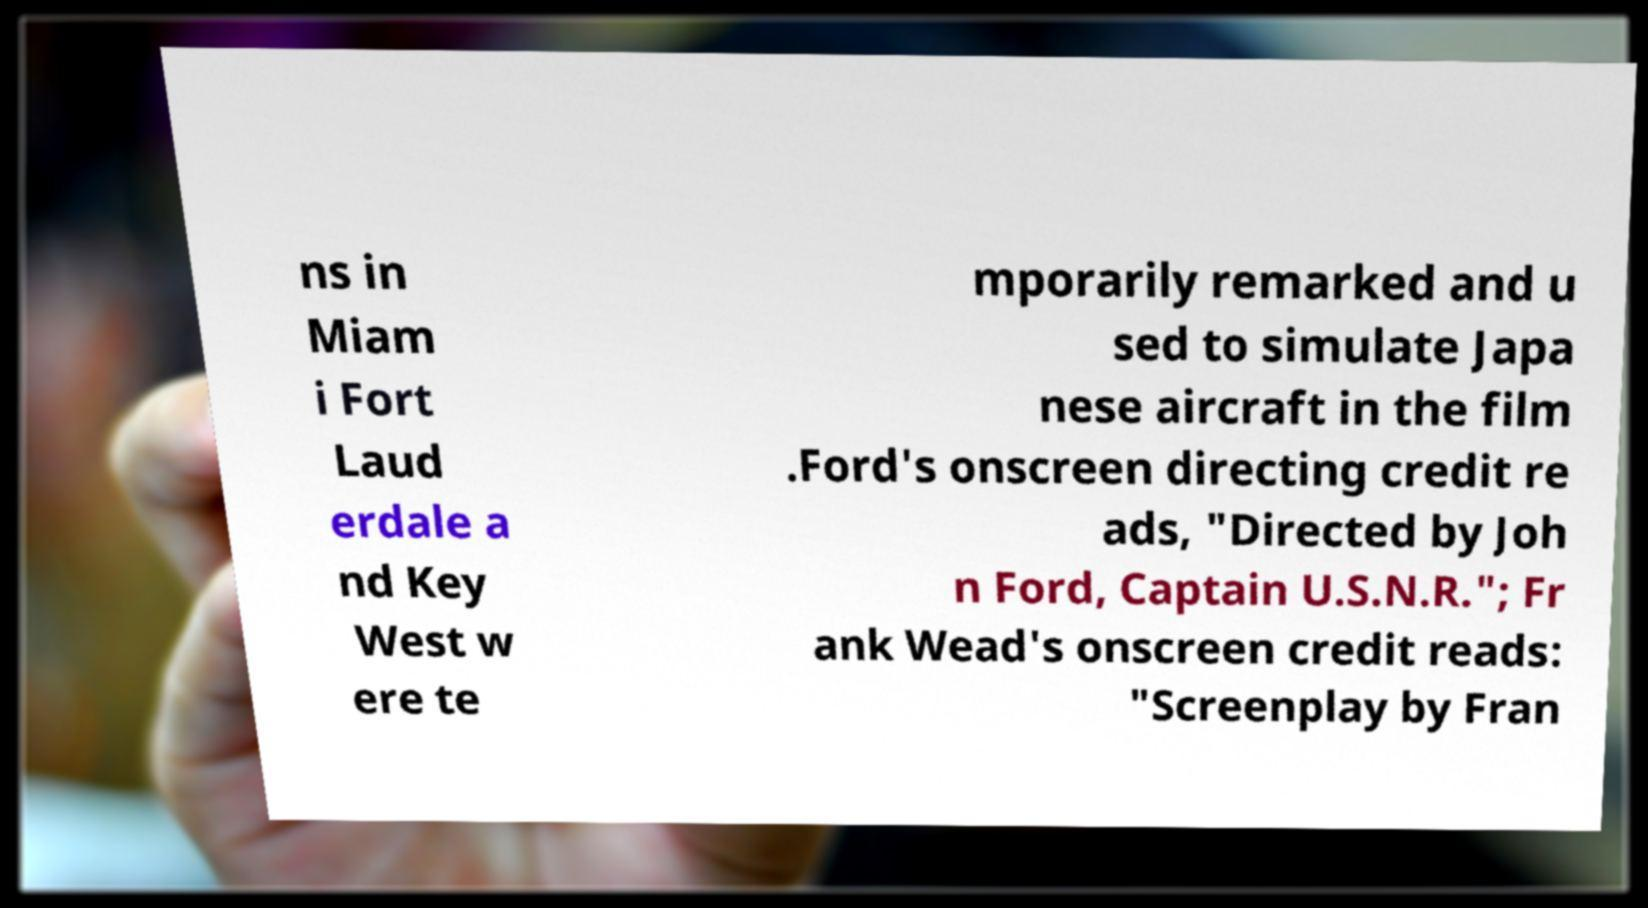Can you read and provide the text displayed in the image?This photo seems to have some interesting text. Can you extract and type it out for me? ns in Miam i Fort Laud erdale a nd Key West w ere te mporarily remarked and u sed to simulate Japa nese aircraft in the film .Ford's onscreen directing credit re ads, "Directed by Joh n Ford, Captain U.S.N.R."; Fr ank Wead's onscreen credit reads: "Screenplay by Fran 